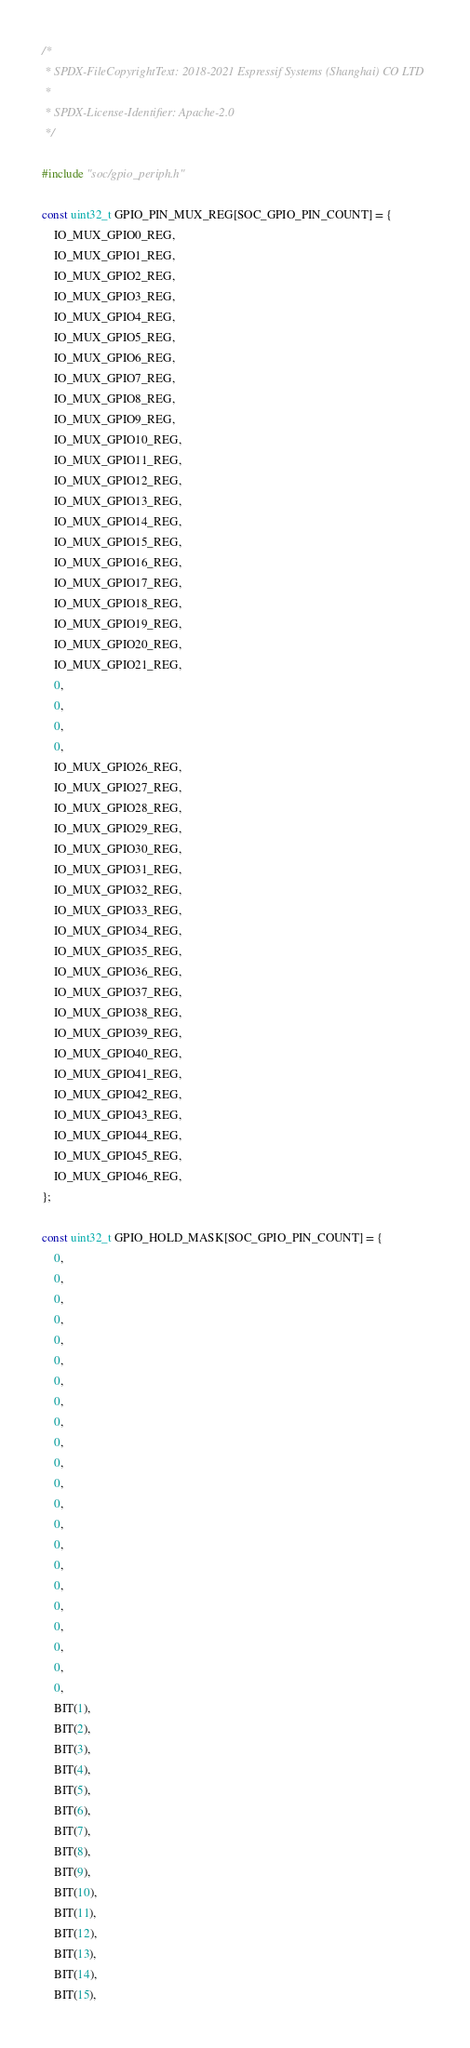<code> <loc_0><loc_0><loc_500><loc_500><_C_>/*
 * SPDX-FileCopyrightText: 2018-2021 Espressif Systems (Shanghai) CO LTD
 *
 * SPDX-License-Identifier: Apache-2.0
 */

#include "soc/gpio_periph.h"

const uint32_t GPIO_PIN_MUX_REG[SOC_GPIO_PIN_COUNT] = {
    IO_MUX_GPIO0_REG,
    IO_MUX_GPIO1_REG,
    IO_MUX_GPIO2_REG,
    IO_MUX_GPIO3_REG,
    IO_MUX_GPIO4_REG,
    IO_MUX_GPIO5_REG,
    IO_MUX_GPIO6_REG,
    IO_MUX_GPIO7_REG,
    IO_MUX_GPIO8_REG,
    IO_MUX_GPIO9_REG,
    IO_MUX_GPIO10_REG,
    IO_MUX_GPIO11_REG,
    IO_MUX_GPIO12_REG,
    IO_MUX_GPIO13_REG,
    IO_MUX_GPIO14_REG,
    IO_MUX_GPIO15_REG,
    IO_MUX_GPIO16_REG,
    IO_MUX_GPIO17_REG,
    IO_MUX_GPIO18_REG,
    IO_MUX_GPIO19_REG,
    IO_MUX_GPIO20_REG,
    IO_MUX_GPIO21_REG,
    0,
    0,
    0,
    0,
    IO_MUX_GPIO26_REG,
    IO_MUX_GPIO27_REG,
    IO_MUX_GPIO28_REG,
    IO_MUX_GPIO29_REG,
    IO_MUX_GPIO30_REG,
    IO_MUX_GPIO31_REG,
    IO_MUX_GPIO32_REG,
    IO_MUX_GPIO33_REG,
    IO_MUX_GPIO34_REG,
    IO_MUX_GPIO35_REG,
    IO_MUX_GPIO36_REG,
    IO_MUX_GPIO37_REG,
    IO_MUX_GPIO38_REG,
    IO_MUX_GPIO39_REG,
    IO_MUX_GPIO40_REG,
    IO_MUX_GPIO41_REG,
    IO_MUX_GPIO42_REG,
    IO_MUX_GPIO43_REG,
    IO_MUX_GPIO44_REG,
    IO_MUX_GPIO45_REG,
    IO_MUX_GPIO46_REG,
};

const uint32_t GPIO_HOLD_MASK[SOC_GPIO_PIN_COUNT] = {
    0,
    0,
    0,
    0,
    0,
    0,
    0,
    0,
    0,
    0,
    0,
    0,
    0,
    0,
    0,
    0,
    0,
    0,
    0,
    0,
    0,
    0,
    BIT(1),
    BIT(2),
    BIT(3),
    BIT(4),
    BIT(5),
    BIT(6),
    BIT(7),
    BIT(8),
    BIT(9),
    BIT(10),
    BIT(11),
    BIT(12),
    BIT(13),
    BIT(14),
    BIT(15),</code> 